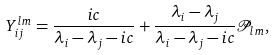<formula> <loc_0><loc_0><loc_500><loc_500>Y _ { i j } ^ { l m } = \frac { i c } { \lambda _ { i } - \lambda _ { j } - i c } + \frac { \lambda _ { i } - \lambda _ { j } } { \lambda _ { i } - \lambda _ { j } - i c } { \mathcal { P } } _ { l m } ,</formula> 